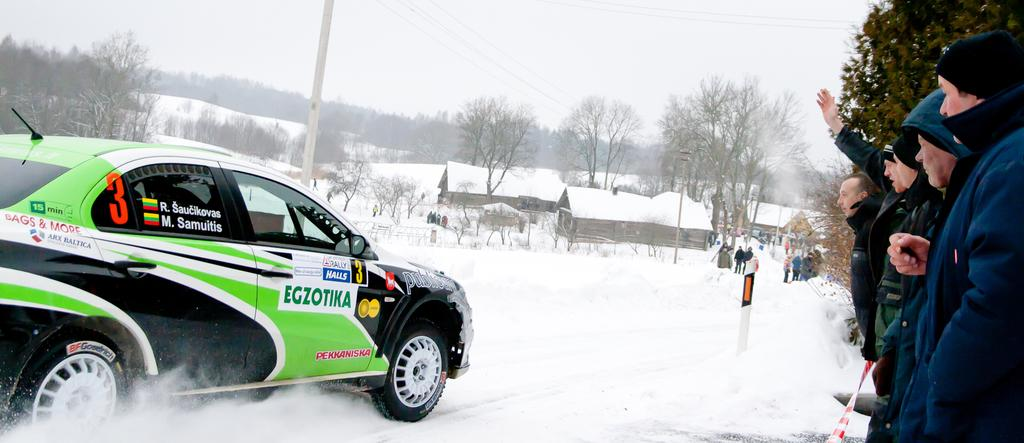What type of structures can be seen in the image? There are houses in the image. What other natural elements are present in the image? There are trees in the image. Can you describe any man-made objects in the image? There is a pole in the image. What mode of transportation is visible in the image? There is a car in the image. Are there any people present in the image? Yes, there are people standing in the image. What action is one of the people performing? A man is waving his hand in the image. How would you describe the weather in the image? The sky is cloudy, and there is snow visible in the image, suggesting a cold and possibly snowy day. What is the opinion of the kitty about the snow in the image? There is no kitty present in the image, so it is not possible to determine its opinion about the snow. What is the reason for the man waving his hand in the image? The image does not provide any information about the reason for the man waving his hand, so it cannot be determined from the image alone. 